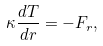<formula> <loc_0><loc_0><loc_500><loc_500>\kappa \frac { d T } { d r } = - F _ { r } ,</formula> 